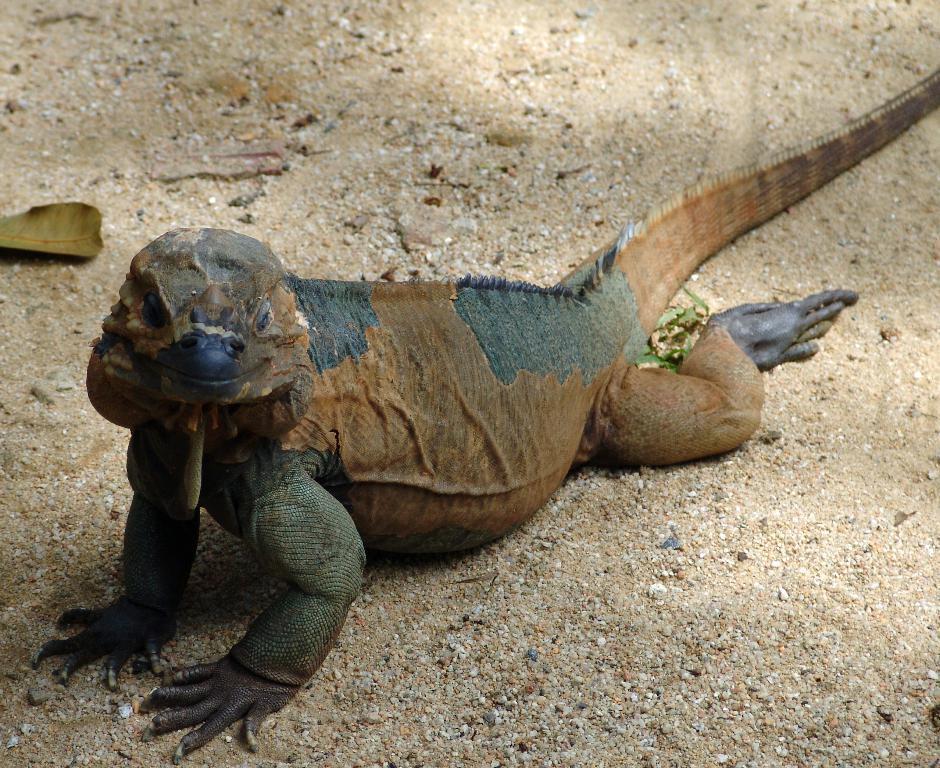Please provide a concise description of this image. In the picture I can see different kind of reptile on the ground. Here I can see some dry leaves. 